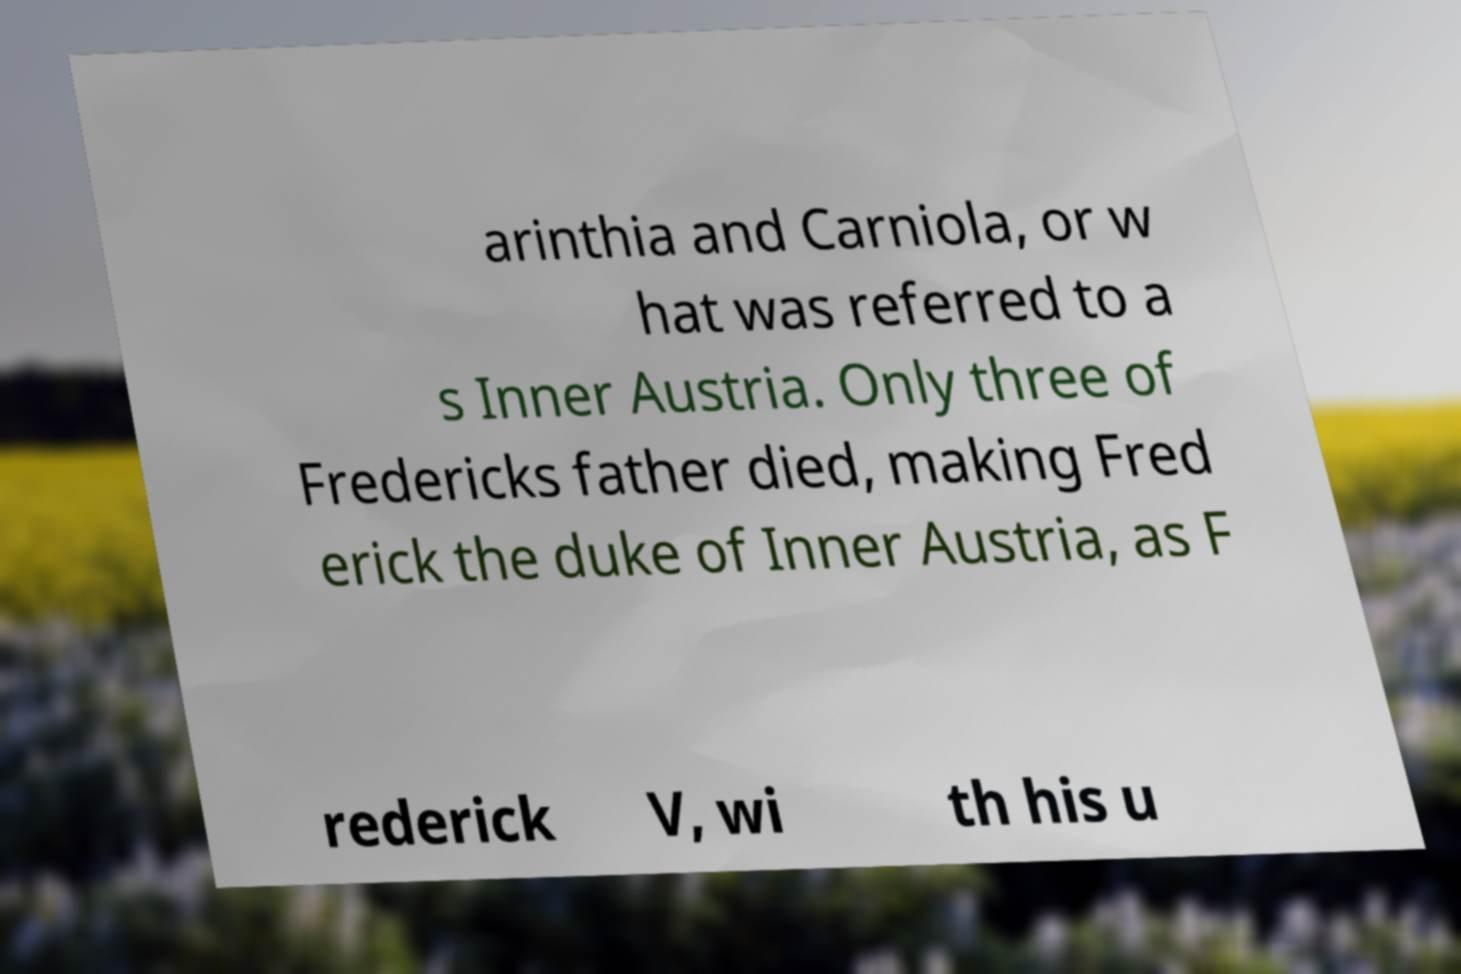Please read and relay the text visible in this image. What does it say? arinthia and Carniola, or w hat was referred to a s Inner Austria. Only three of Fredericks father died, making Fred erick the duke of Inner Austria, as F rederick V, wi th his u 